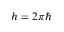<formula> <loc_0><loc_0><loc_500><loc_500>h = 2 \pi \hbar</formula> 